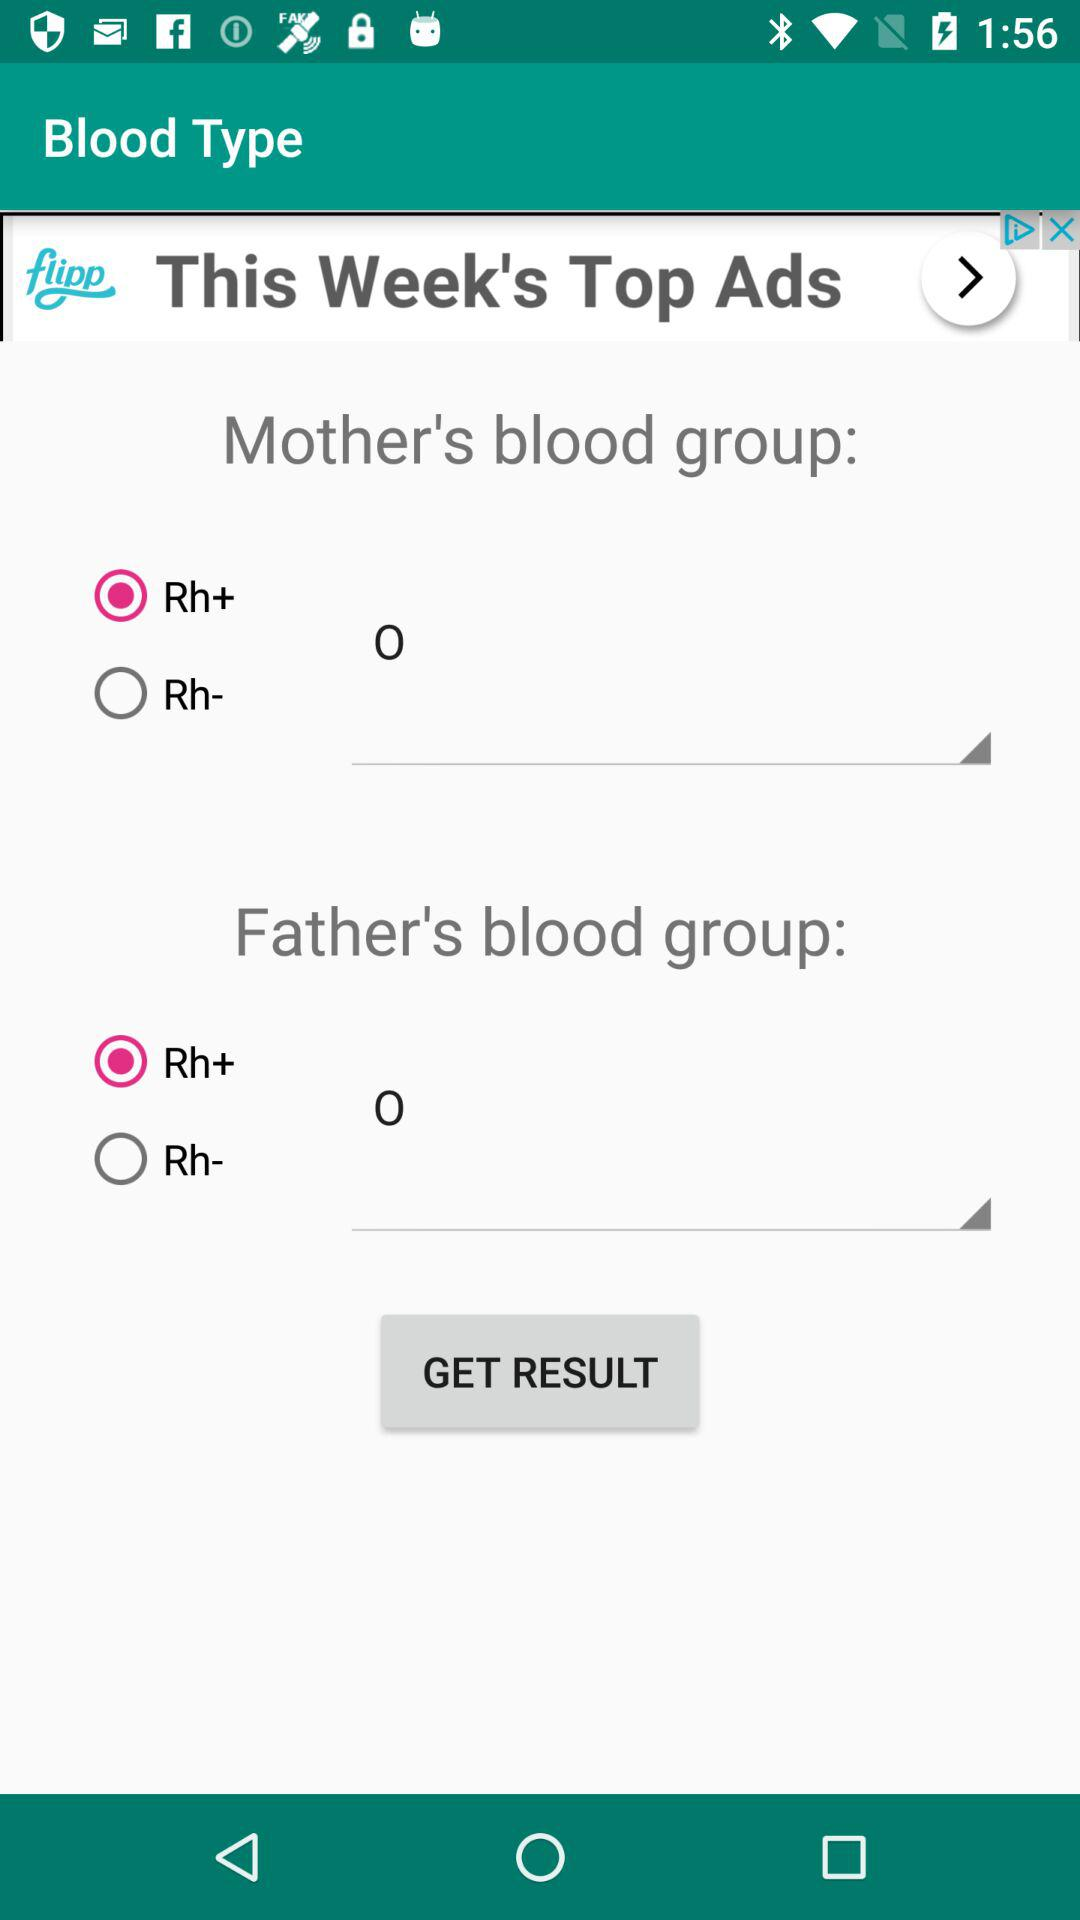Which option is selected for "Father's blood group"? The selected option is "Rh+". 